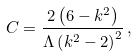<formula> <loc_0><loc_0><loc_500><loc_500>C = \frac { 2 \left ( 6 - k ^ { 2 } \right ) } { \Lambda \left ( k ^ { 2 } - 2 \right ) ^ { 2 } } \, ,</formula> 